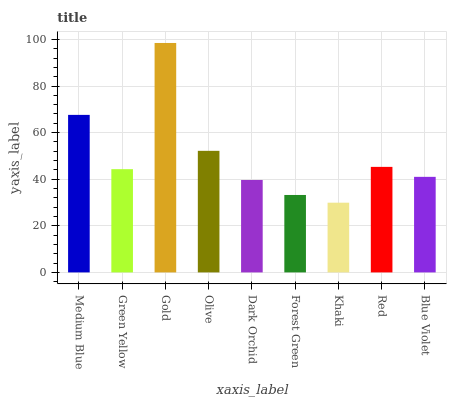Is Green Yellow the minimum?
Answer yes or no. No. Is Green Yellow the maximum?
Answer yes or no. No. Is Medium Blue greater than Green Yellow?
Answer yes or no. Yes. Is Green Yellow less than Medium Blue?
Answer yes or no. Yes. Is Green Yellow greater than Medium Blue?
Answer yes or no. No. Is Medium Blue less than Green Yellow?
Answer yes or no. No. Is Green Yellow the high median?
Answer yes or no. Yes. Is Green Yellow the low median?
Answer yes or no. Yes. Is Red the high median?
Answer yes or no. No. Is Olive the low median?
Answer yes or no. No. 